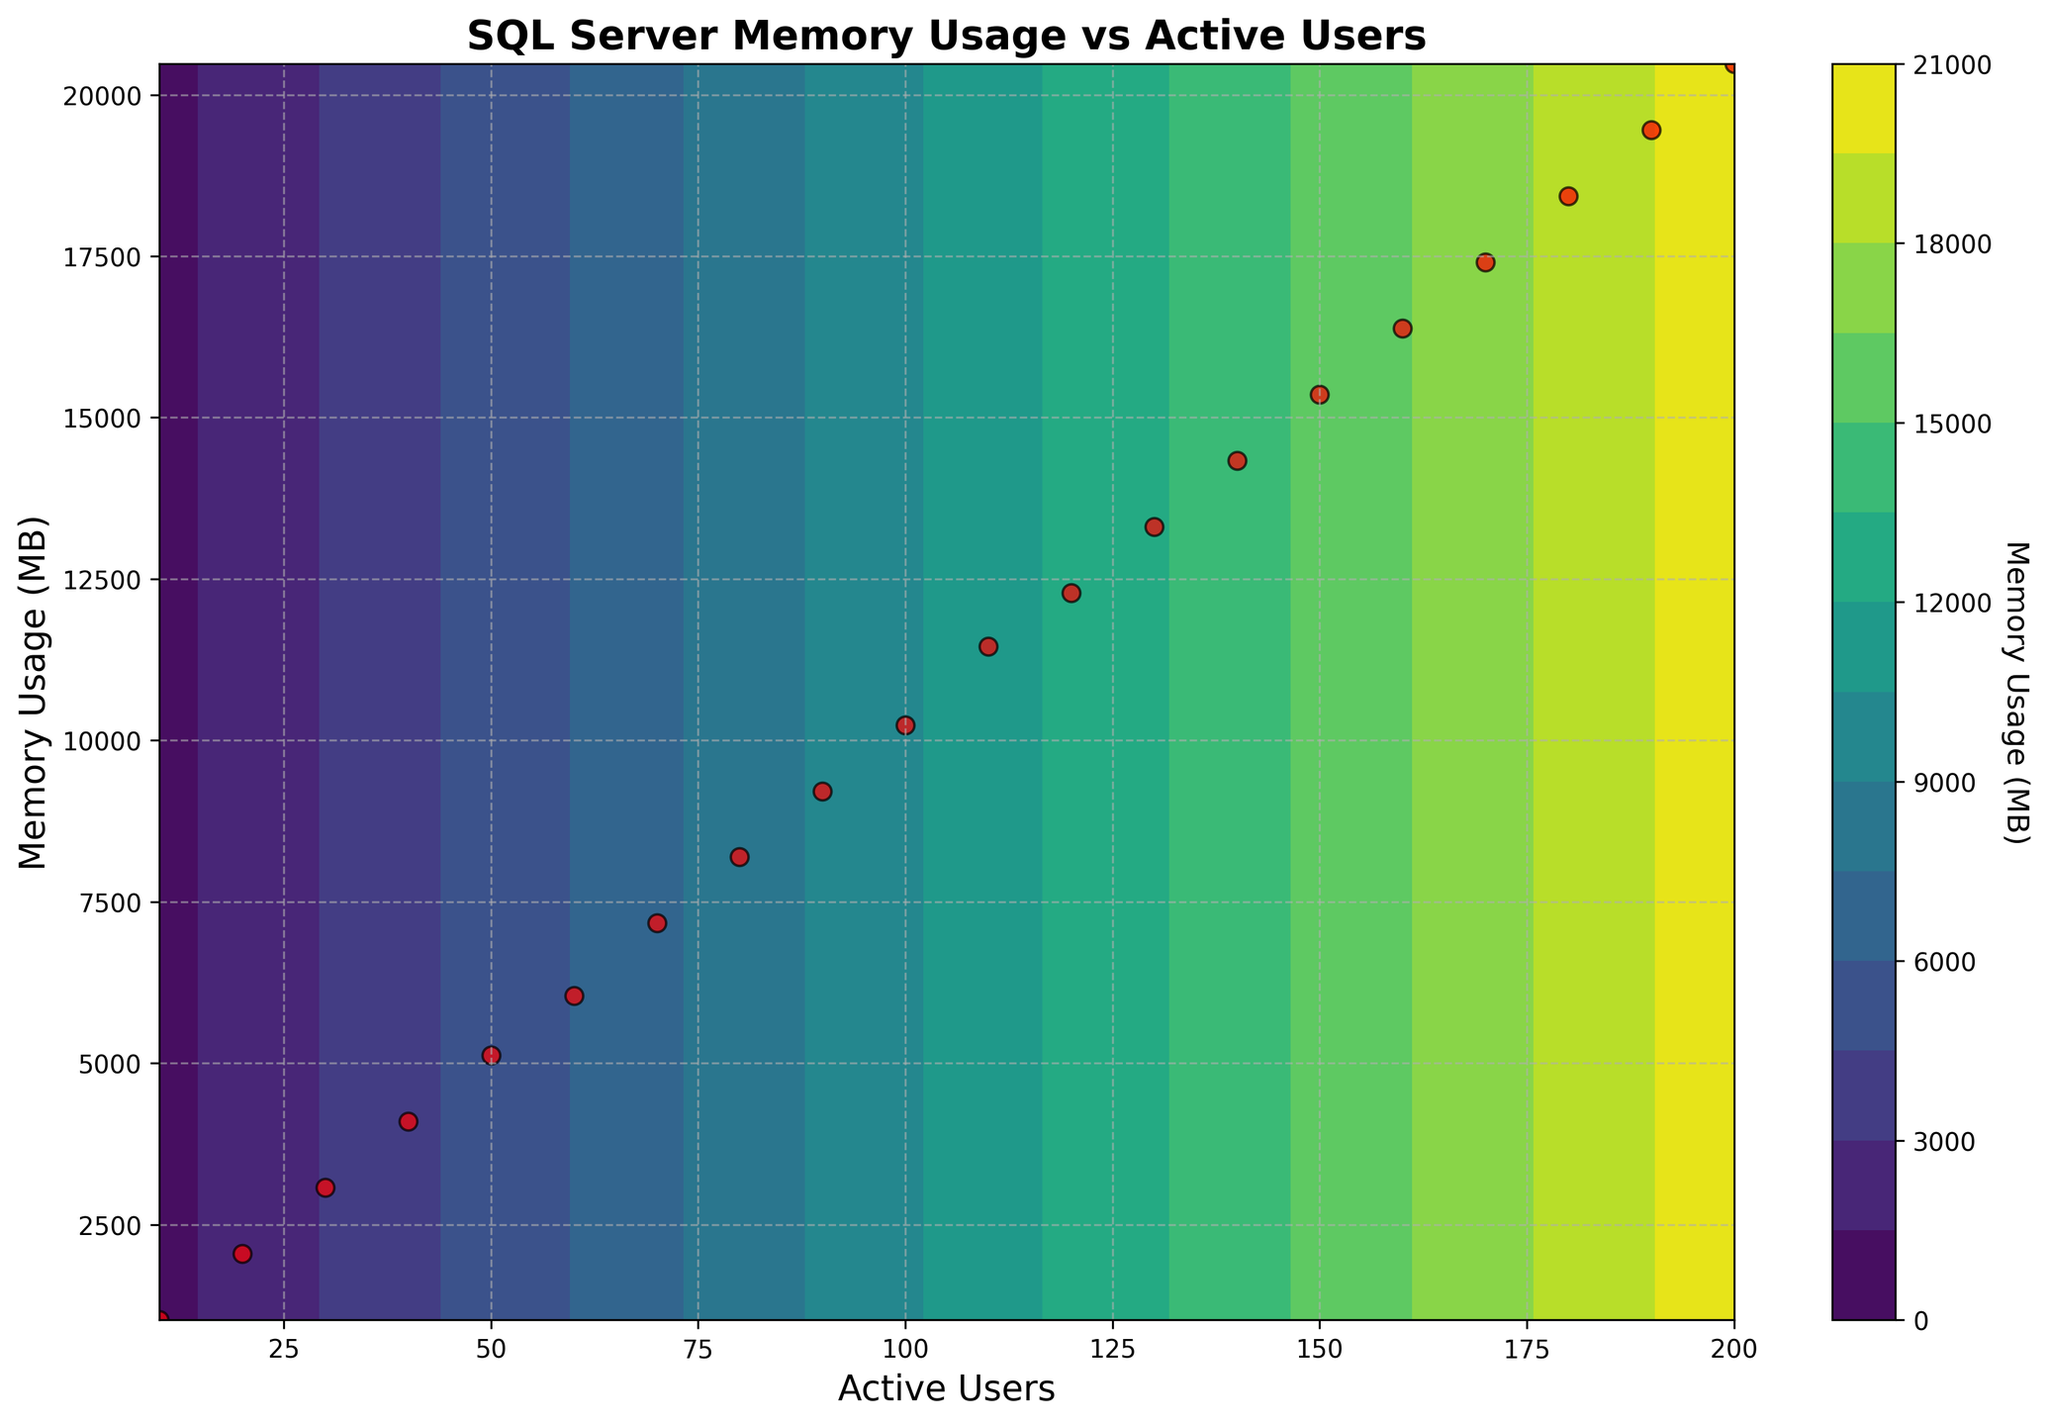What's the title of the plot? The title of the plot can be found at the top of the figure and provides a summary of what the plot is about.
Answer: SQL Server Memory Usage vs Active Users How many data points are there in the graph? The red scatter points on the contour plot represent the original data, and counting these points gives the number of data points.
Answer: 20 What are the units of the color bar and what does it represent? The label on the color bar indicates what it represents and its units are specified beside the label.
Answer: Memory Usage (MB) What is the memory usage when there are 100 active users? To find the memory usage for 100 active users, locate the corresponding scatter point and refer to the y-axis value.
Answer: 10240 MB What is the range of active users covered in the plot? The x-axis shows the range of active users, which can be determined by looking at the minimum and maximum values.
Answer: 10 to 200 Which contour level indicates the maximum memory usage, and what is that usage? The highest contour level, which is represented by the darkest color, indicates the maximum value; refer to the value on the contours' scale to find it.
Answer: 20480 MB Is there a linear relationship between active users and memory usage? To determine if the relationship is linear, observe the scatter points and the contour lines; a straight-line pattern suggests linearity.
Answer: Yes What happens to memory usage as the number of active users increases? By examining the trend in data points and contour lines, observe what happens to memory usage as you move to the right along the x-axis.
Answer: It increases In the initial stage (10 to 60 users), does the memory usage change the same way it does in the later stage (150 to 200 users)? Compare the slope of the contour lines and the change in scatter points between these two stages to determine if the change rate is consistent.
Answer: No, it increases more rapidly in the later stage What is the average memory usage for the given active users? To find the average, sum all the memory usage values from the data points and divide by the number of points.
Answer: 10240 MB 